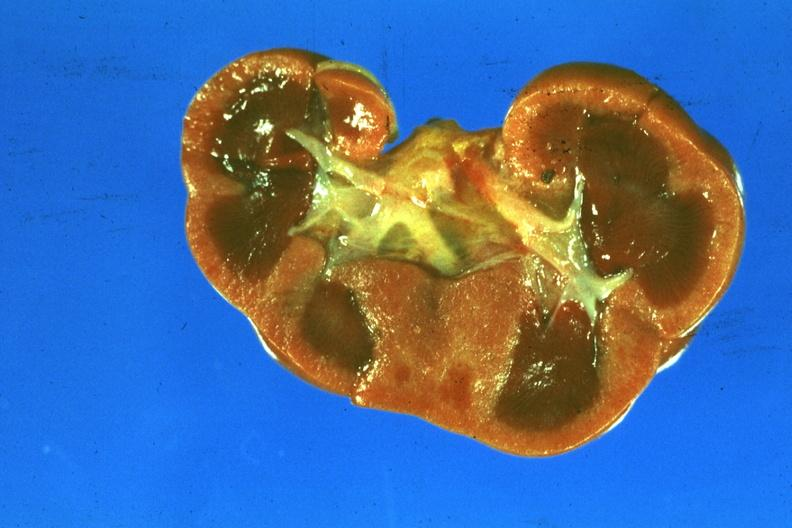where is this?
Answer the question using a single word or phrase. Urinary 